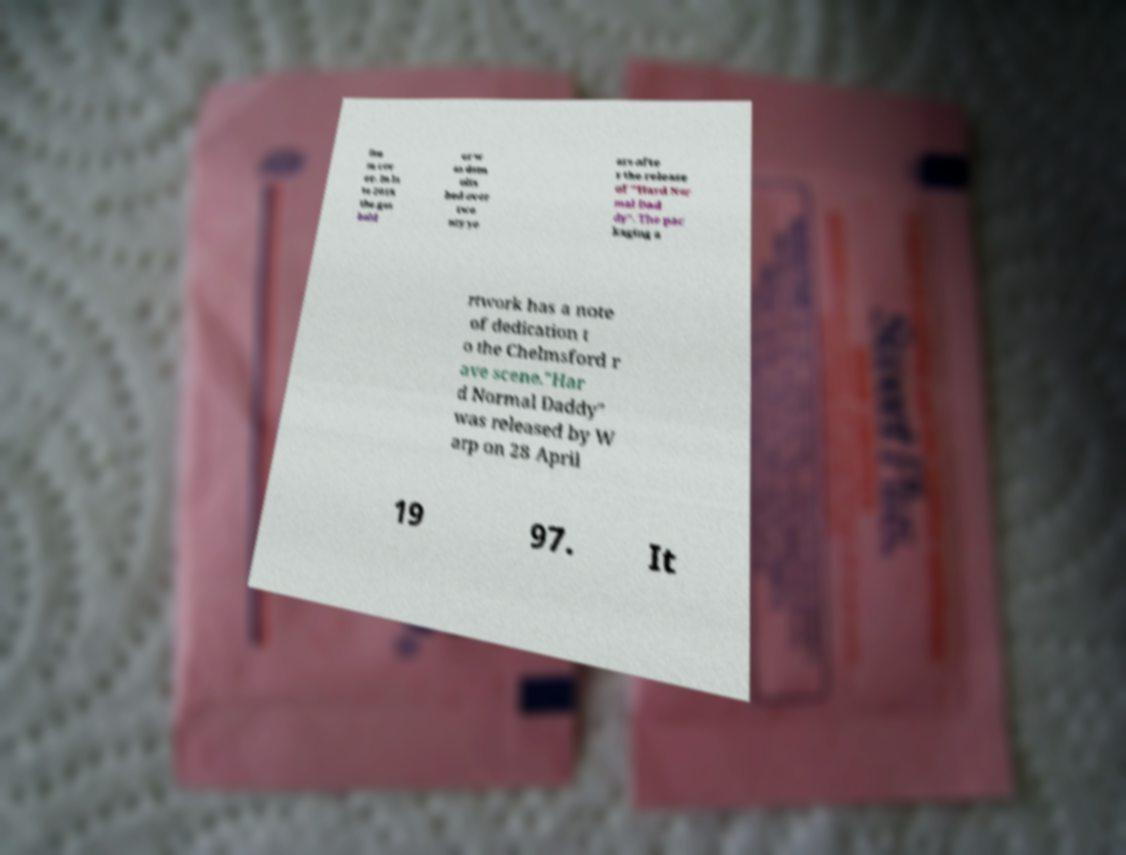Please identify and transcribe the text found in this image. lbu m cov er. In la te 2018 the gas hold er w as dem olis hed over twe nty ye ars afte r the release of "Hard Nor mal Dad dy". The pac kaging a rtwork has a note of dedication t o the Chelmsford r ave scene."Har d Normal Daddy" was released by W arp on 28 April 19 97. It 